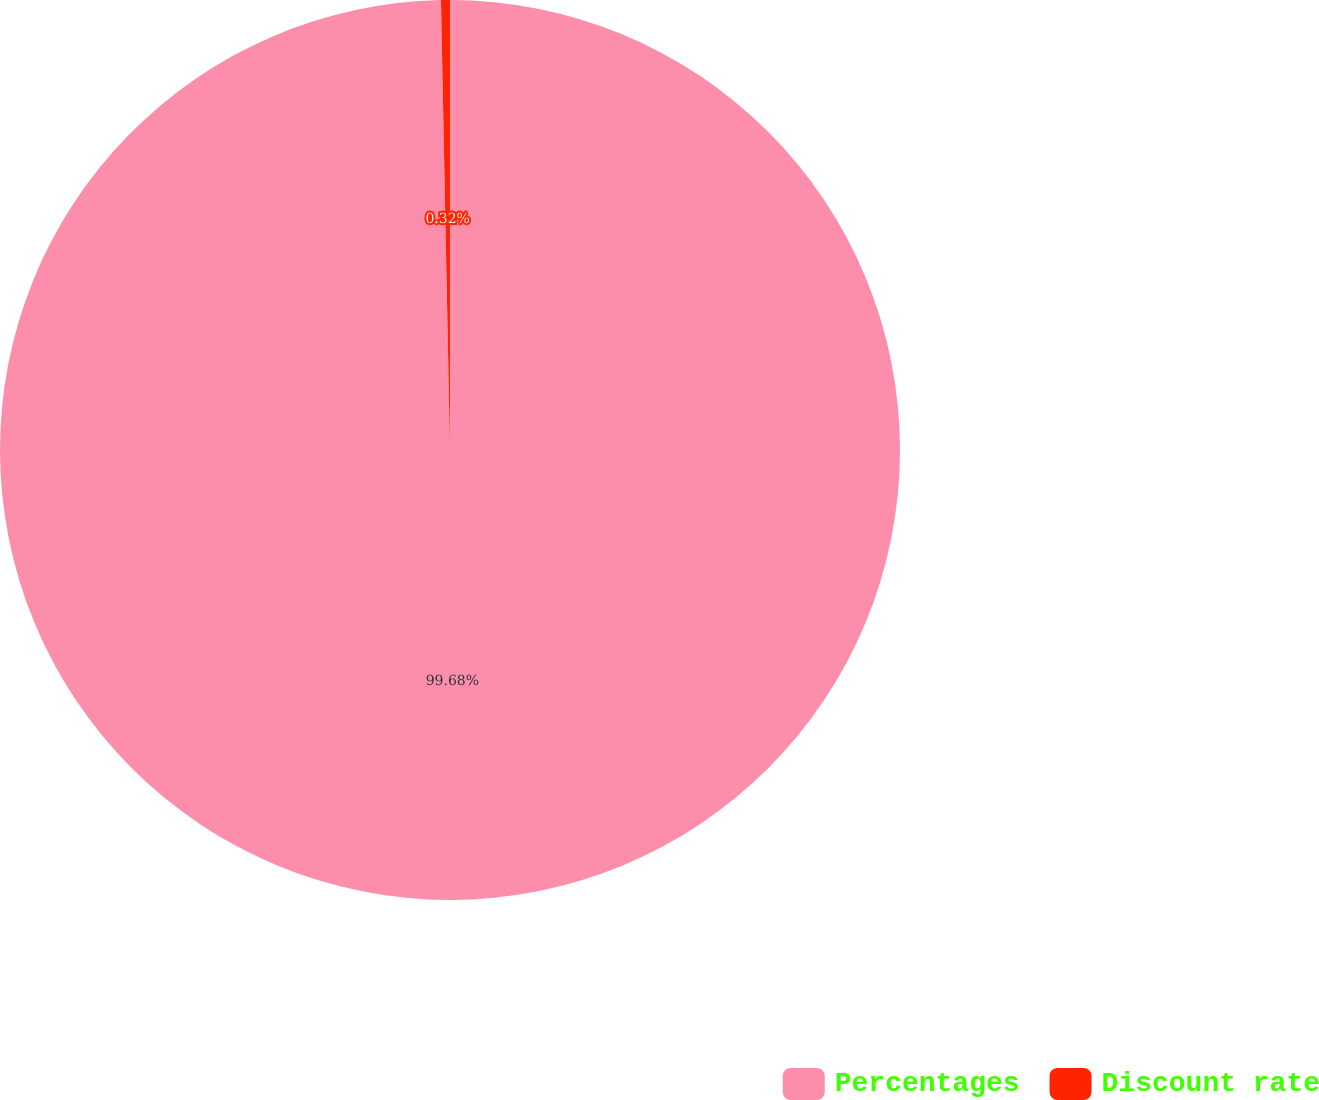Convert chart. <chart><loc_0><loc_0><loc_500><loc_500><pie_chart><fcel>Percentages<fcel>Discount rate<nl><fcel>99.68%<fcel>0.32%<nl></chart> 